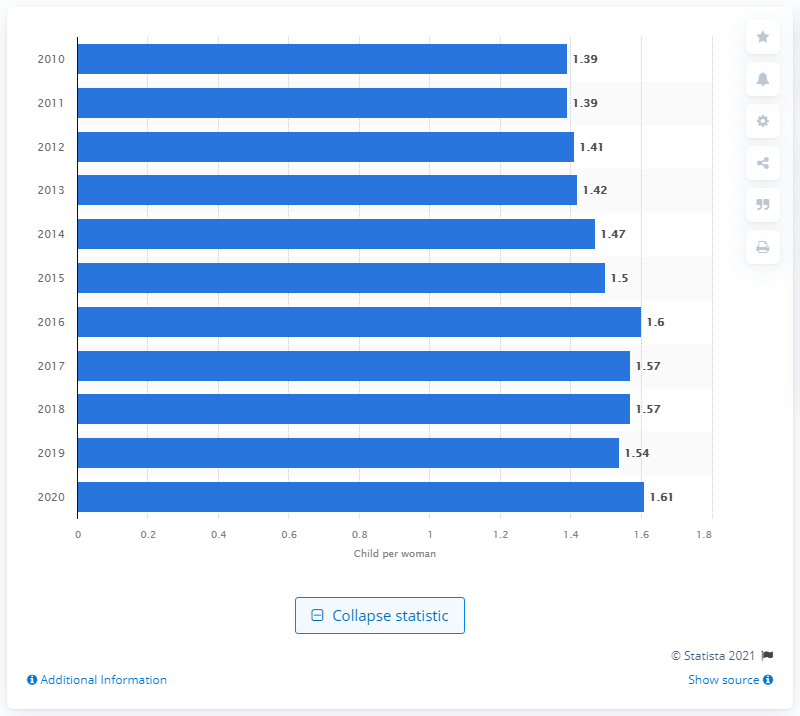Identify some key points in this picture. In 2020, Germany's fertility rate was 1.61. 